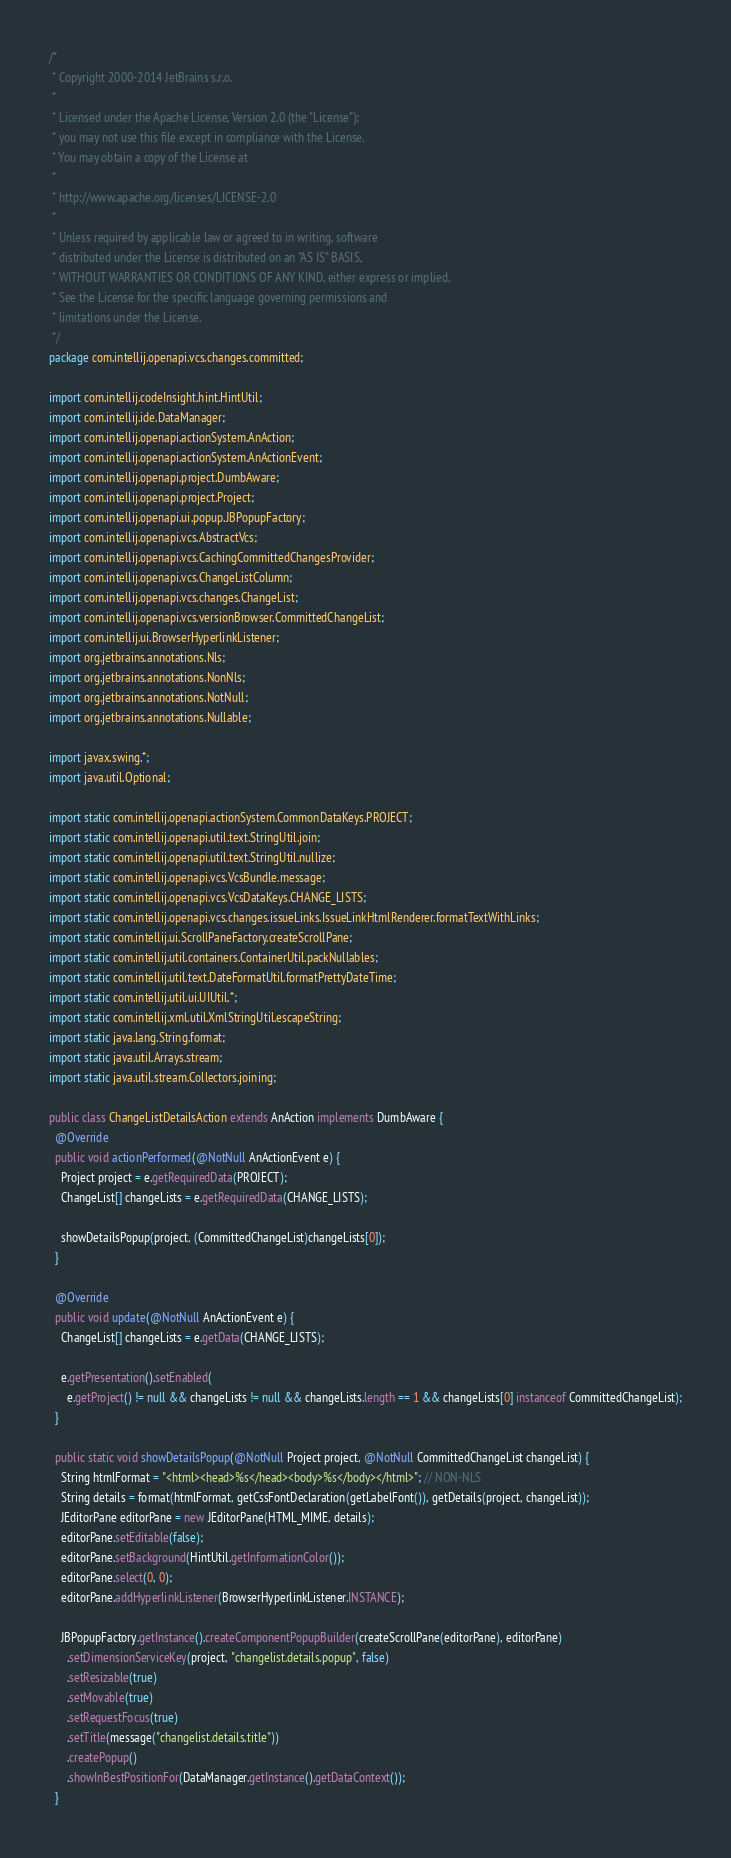Convert code to text. <code><loc_0><loc_0><loc_500><loc_500><_Java_>/*
 * Copyright 2000-2014 JetBrains s.r.o.
 *
 * Licensed under the Apache License, Version 2.0 (the "License");
 * you may not use this file except in compliance with the License.
 * You may obtain a copy of the License at
 *
 * http://www.apache.org/licenses/LICENSE-2.0
 *
 * Unless required by applicable law or agreed to in writing, software
 * distributed under the License is distributed on an "AS IS" BASIS,
 * WITHOUT WARRANTIES OR CONDITIONS OF ANY KIND, either express or implied.
 * See the License for the specific language governing permissions and
 * limitations under the License.
 */
package com.intellij.openapi.vcs.changes.committed;

import com.intellij.codeInsight.hint.HintUtil;
import com.intellij.ide.DataManager;
import com.intellij.openapi.actionSystem.AnAction;
import com.intellij.openapi.actionSystem.AnActionEvent;
import com.intellij.openapi.project.DumbAware;
import com.intellij.openapi.project.Project;
import com.intellij.openapi.ui.popup.JBPopupFactory;
import com.intellij.openapi.vcs.AbstractVcs;
import com.intellij.openapi.vcs.CachingCommittedChangesProvider;
import com.intellij.openapi.vcs.ChangeListColumn;
import com.intellij.openapi.vcs.changes.ChangeList;
import com.intellij.openapi.vcs.versionBrowser.CommittedChangeList;
import com.intellij.ui.BrowserHyperlinkListener;
import org.jetbrains.annotations.Nls;
import org.jetbrains.annotations.NonNls;
import org.jetbrains.annotations.NotNull;
import org.jetbrains.annotations.Nullable;

import javax.swing.*;
import java.util.Optional;

import static com.intellij.openapi.actionSystem.CommonDataKeys.PROJECT;
import static com.intellij.openapi.util.text.StringUtil.join;
import static com.intellij.openapi.util.text.StringUtil.nullize;
import static com.intellij.openapi.vcs.VcsBundle.message;
import static com.intellij.openapi.vcs.VcsDataKeys.CHANGE_LISTS;
import static com.intellij.openapi.vcs.changes.issueLinks.IssueLinkHtmlRenderer.formatTextWithLinks;
import static com.intellij.ui.ScrollPaneFactory.createScrollPane;
import static com.intellij.util.containers.ContainerUtil.packNullables;
import static com.intellij.util.text.DateFormatUtil.formatPrettyDateTime;
import static com.intellij.util.ui.UIUtil.*;
import static com.intellij.xml.util.XmlStringUtil.escapeString;
import static java.lang.String.format;
import static java.util.Arrays.stream;
import static java.util.stream.Collectors.joining;

public class ChangeListDetailsAction extends AnAction implements DumbAware {
  @Override
  public void actionPerformed(@NotNull AnActionEvent e) {
    Project project = e.getRequiredData(PROJECT);
    ChangeList[] changeLists = e.getRequiredData(CHANGE_LISTS);

    showDetailsPopup(project, (CommittedChangeList)changeLists[0]);
  }

  @Override
  public void update(@NotNull AnActionEvent e) {
    ChangeList[] changeLists = e.getData(CHANGE_LISTS);

    e.getPresentation().setEnabled(
      e.getProject() != null && changeLists != null && changeLists.length == 1 && changeLists[0] instanceof CommittedChangeList);
  }

  public static void showDetailsPopup(@NotNull Project project, @NotNull CommittedChangeList changeList) {
    String htmlFormat = "<html><head>%s</head><body>%s</body></html>"; // NON-NLS
    String details = format(htmlFormat, getCssFontDeclaration(getLabelFont()), getDetails(project, changeList));
    JEditorPane editorPane = new JEditorPane(HTML_MIME, details);
    editorPane.setEditable(false);
    editorPane.setBackground(HintUtil.getInformationColor());
    editorPane.select(0, 0);
    editorPane.addHyperlinkListener(BrowserHyperlinkListener.INSTANCE);

    JBPopupFactory.getInstance().createComponentPopupBuilder(createScrollPane(editorPane), editorPane)
      .setDimensionServiceKey(project, "changelist.details.popup", false)
      .setResizable(true)
      .setMovable(true)
      .setRequestFocus(true)
      .setTitle(message("changelist.details.title"))
      .createPopup()
      .showInBestPositionFor(DataManager.getInstance().getDataContext());
  }
</code> 